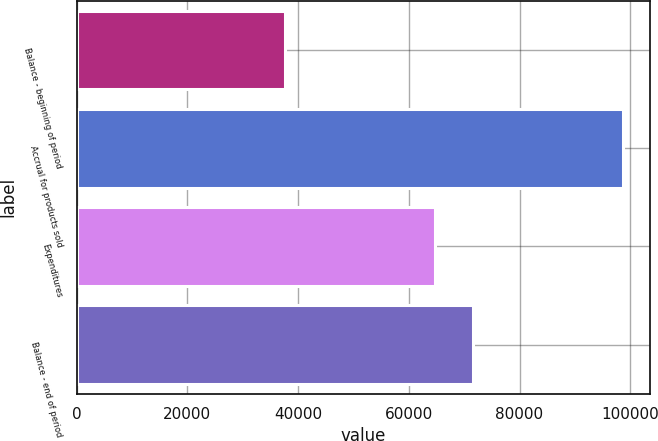<chart> <loc_0><loc_0><loc_500><loc_500><bar_chart><fcel>Balance - beginning of period<fcel>Accrual for products sold<fcel>Expenditures<fcel>Balance - end of period<nl><fcel>37639<fcel>98702<fcel>64705<fcel>71636<nl></chart> 